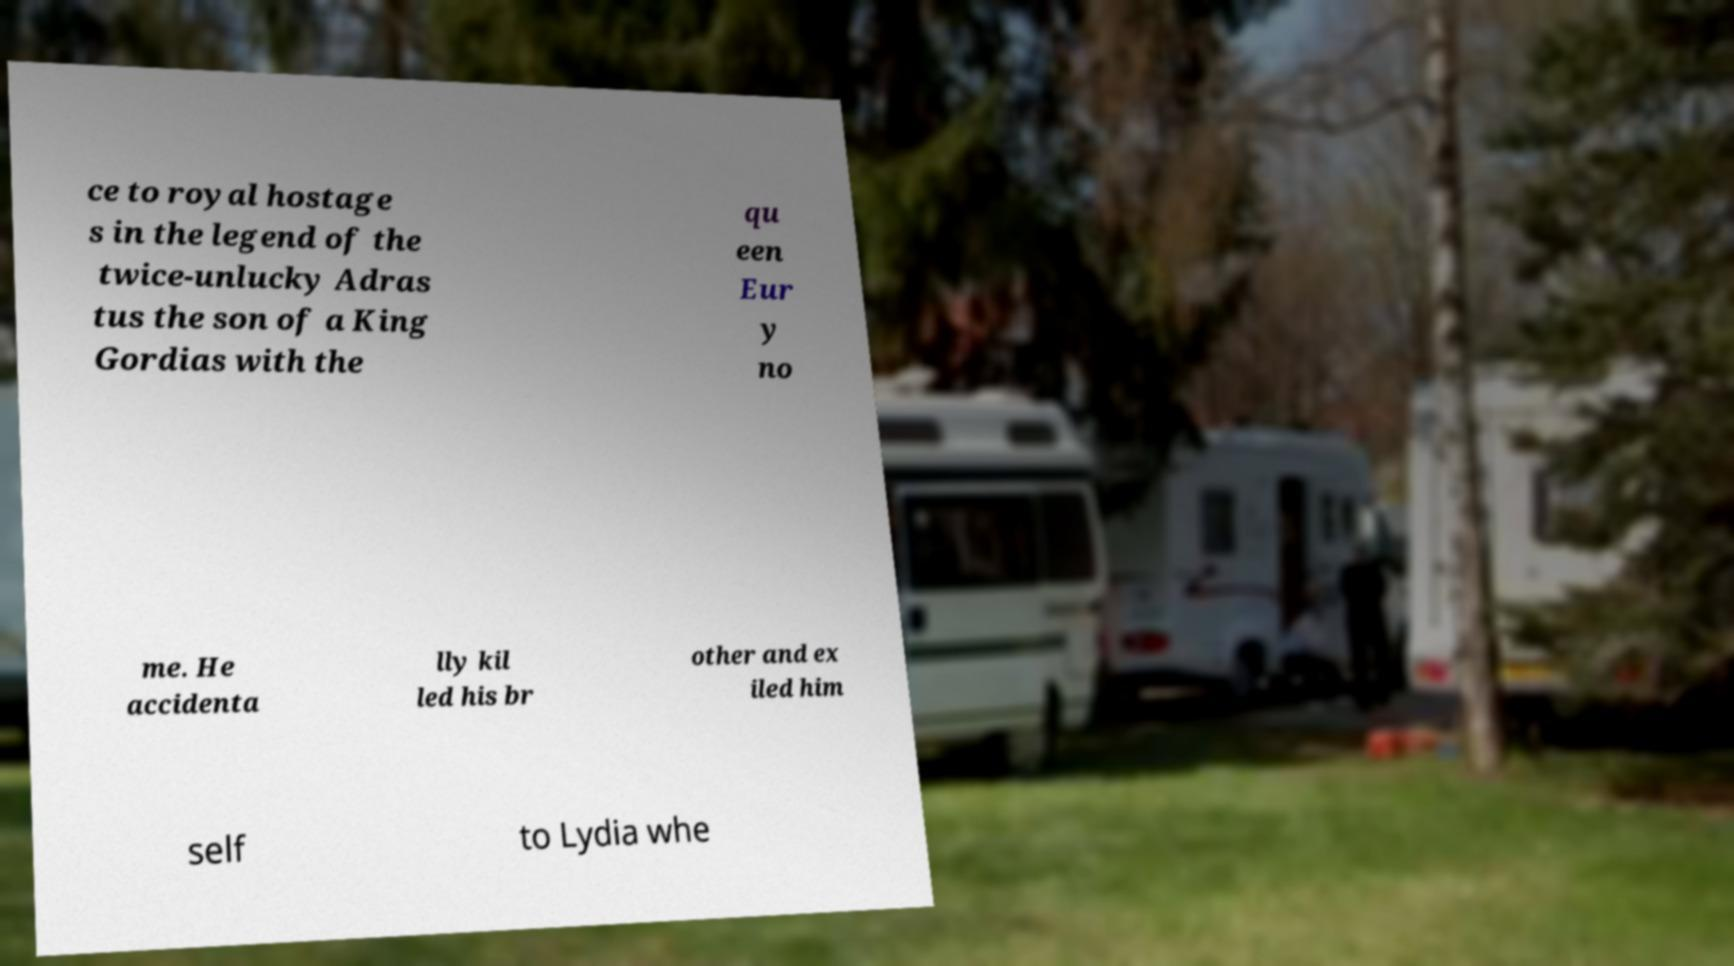Can you accurately transcribe the text from the provided image for me? ce to royal hostage s in the legend of the twice-unlucky Adras tus the son of a King Gordias with the qu een Eur y no me. He accidenta lly kil led his br other and ex iled him self to Lydia whe 